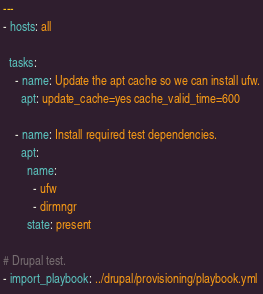<code> <loc_0><loc_0><loc_500><loc_500><_YAML_>---
- hosts: all

  tasks:
    - name: Update the apt cache so we can install ufw.
      apt: update_cache=yes cache_valid_time=600

    - name: Install required test dependencies.
      apt:
        name:
          - ufw
          - dirmngr
        state: present

# Drupal test.
- import_playbook: ../drupal/provisioning/playbook.yml
</code> 